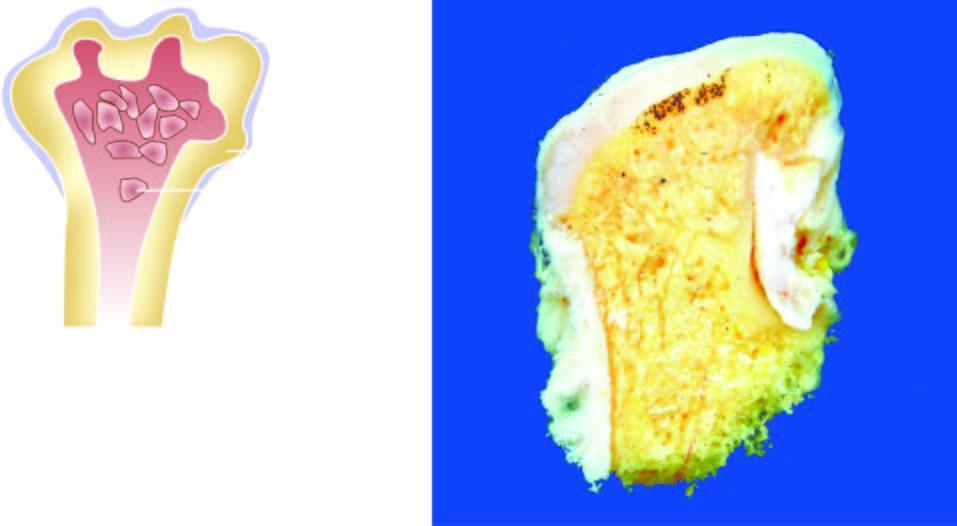what does the amputated head of the long bone show?
Answer the question using a single word or phrase. Mushroom-shaped elevated nodular areas 